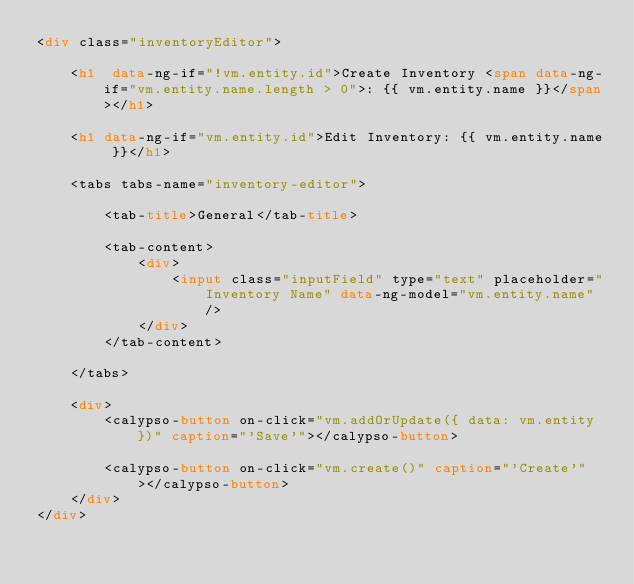<code> <loc_0><loc_0><loc_500><loc_500><_HTML_><div class="inventoryEditor">

    <h1  data-ng-if="!vm.entity.id">Create Inventory <span data-ng-if="vm.entity.name.length > 0">: {{ vm.entity.name }}</span></h1>

    <h1 data-ng-if="vm.entity.id">Edit Inventory: {{ vm.entity.name }}</h1>

    <tabs tabs-name="inventory-editor">

        <tab-title>General</tab-title>

        <tab-content>
            <div>
                <input class="inputField" type="text" placeholder="Inventory Name" data-ng-model="vm.entity.name" />
            </div>
        </tab-content>

    </tabs>

    <div>
        <calypso-button on-click="vm.addOrUpdate({ data: vm.entity })" caption="'Save'"></calypso-button>

        <calypso-button on-click="vm.create()" caption="'Create'"></calypso-button>
    </div>
</div>
</code> 